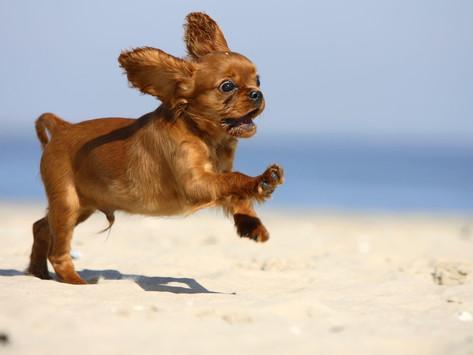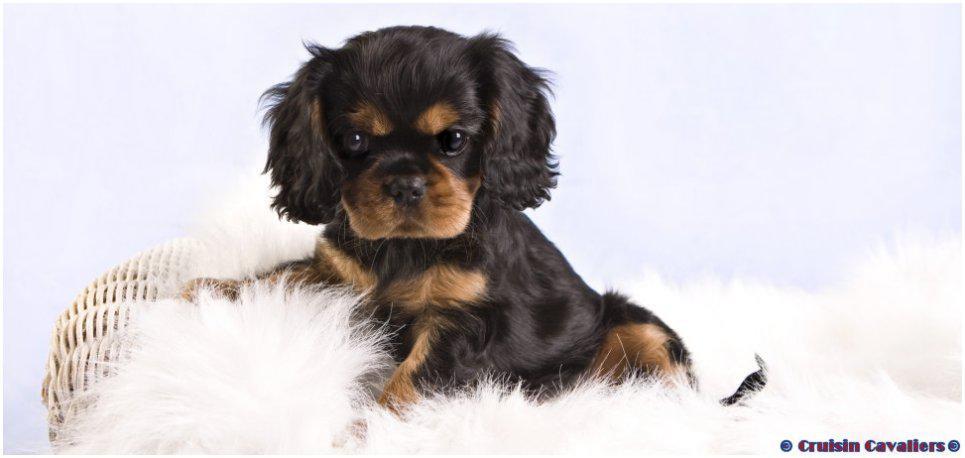The first image is the image on the left, the second image is the image on the right. Analyze the images presented: Is the assertion "There are three cocker spaniels" valid? Answer yes or no. No. The first image is the image on the left, the second image is the image on the right. Evaluate the accuracy of this statement regarding the images: "One image shows a black and brown spaniel standing and looking up at the camera.". Is it true? Answer yes or no. No. 